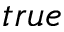<formula> <loc_0><loc_0><loc_500><loc_500>t r u e</formula> 